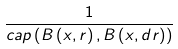Convert formula to latex. <formula><loc_0><loc_0><loc_500><loc_500>\frac { 1 } { c a p \left ( B \left ( x , r \right ) , B \left ( x , d r \right ) \right ) }</formula> 